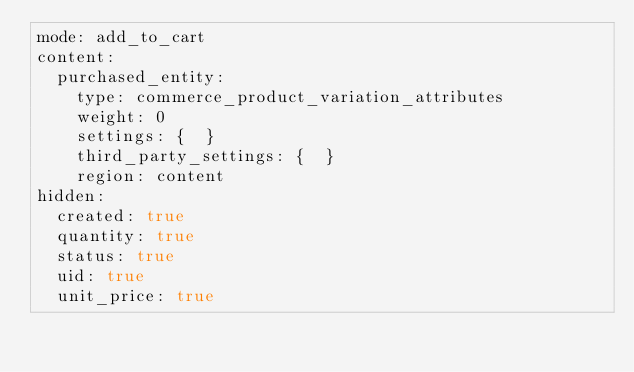Convert code to text. <code><loc_0><loc_0><loc_500><loc_500><_YAML_>mode: add_to_cart
content:
  purchased_entity:
    type: commerce_product_variation_attributes
    weight: 0
    settings: {  }
    third_party_settings: {  }
    region: content
hidden:
  created: true
  quantity: true
  status: true
  uid: true
  unit_price: true
</code> 